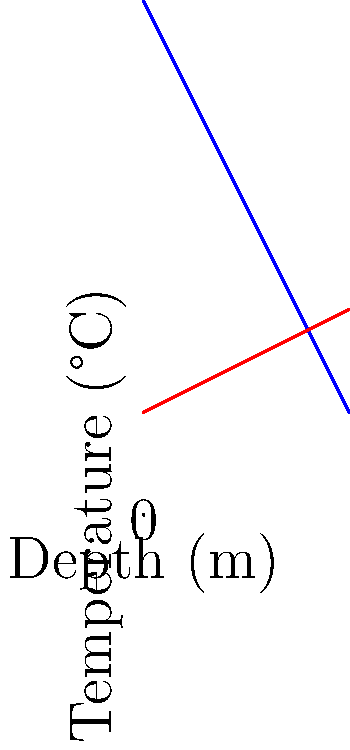As a geologist exploring geothermal potential, you encounter a heat exchanger system in a newly discovered mineral-rich area. The graph shows the temperature profiles of the surrounding rock and the circulating fluid in the heat exchanger. Given that the rock temperature decreases linearly with depth at a rate of 2°C/m and the fluid temperature increases at 0.5°C/m, at what depth (in meters) do the rock and fluid temperatures equalize? To solve this problem, we need to follow these steps:

1) First, let's define the equations for rock and fluid temperatures as functions of depth (x):

   Rock temperature: $T_r = 100 - 2x$
   Fluid temperature: $T_f = 20 + 0.5x$

2) At the point where temperatures equalize, $T_r = T_f$. So we can set up the equation:

   $100 - 2x = 20 + 0.5x$

3) Now, let's solve this equation:
   
   $100 - 2x = 20 + 0.5x$
   $80 = 2.5x$
   $x = 80 / 2.5 = 32$

4) We can verify this by plugging x = 32 into both original equations:

   Rock: $T_r = 100 - 2(32) = 100 - 64 = 36°C$
   Fluid: $T_f = 20 + 0.5(32) = 20 + 16 = 36°C$

Therefore, the rock and fluid temperatures equalize at a depth of 32 meters.
Answer: 32 meters 